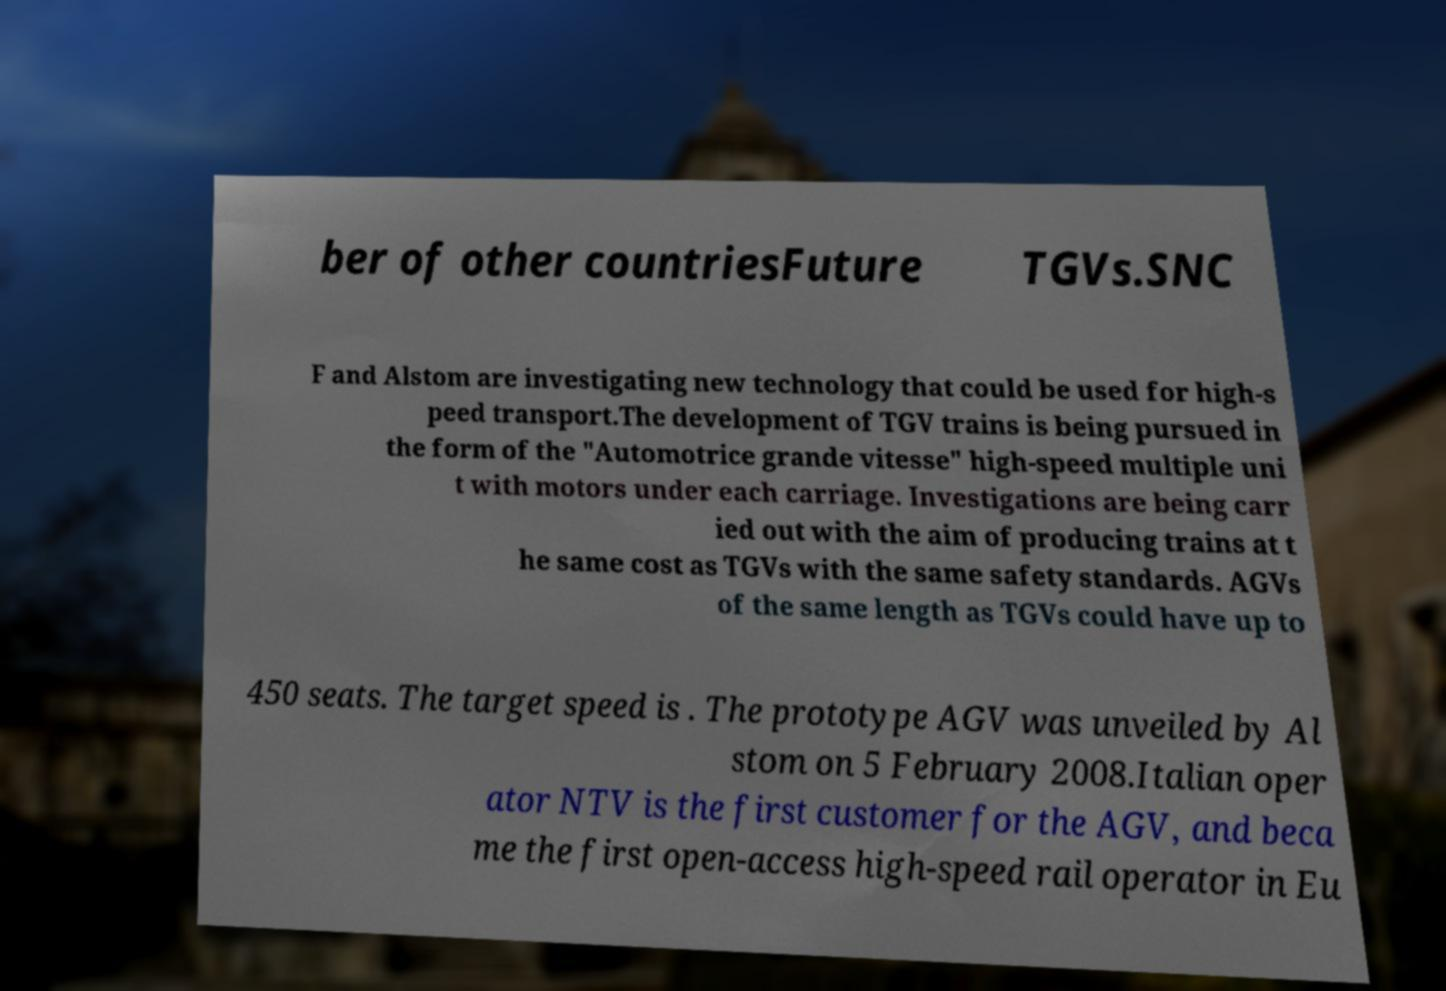Could you extract and type out the text from this image? ber of other countriesFuture TGVs.SNC F and Alstom are investigating new technology that could be used for high-s peed transport.The development of TGV trains is being pursued in the form of the "Automotrice grande vitesse" high-speed multiple uni t with motors under each carriage. Investigations are being carr ied out with the aim of producing trains at t he same cost as TGVs with the same safety standards. AGVs of the same length as TGVs could have up to 450 seats. The target speed is . The prototype AGV was unveiled by Al stom on 5 February 2008.Italian oper ator NTV is the first customer for the AGV, and beca me the first open-access high-speed rail operator in Eu 